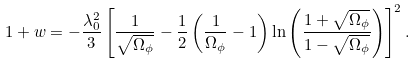Convert formula to latex. <formula><loc_0><loc_0><loc_500><loc_500>1 + w = - \frac { \lambda _ { 0 } ^ { 2 } } { 3 } \left [ \frac { 1 } { \sqrt { \Omega _ { \phi } } } - \frac { 1 } { 2 } \left ( \frac { 1 } { \Omega _ { \phi } } - 1 \right ) \ln \left ( \frac { 1 + \sqrt { \Omega _ { \phi } } } { 1 - \sqrt { \Omega _ { \phi } } } \right ) \right ] ^ { 2 } .</formula> 